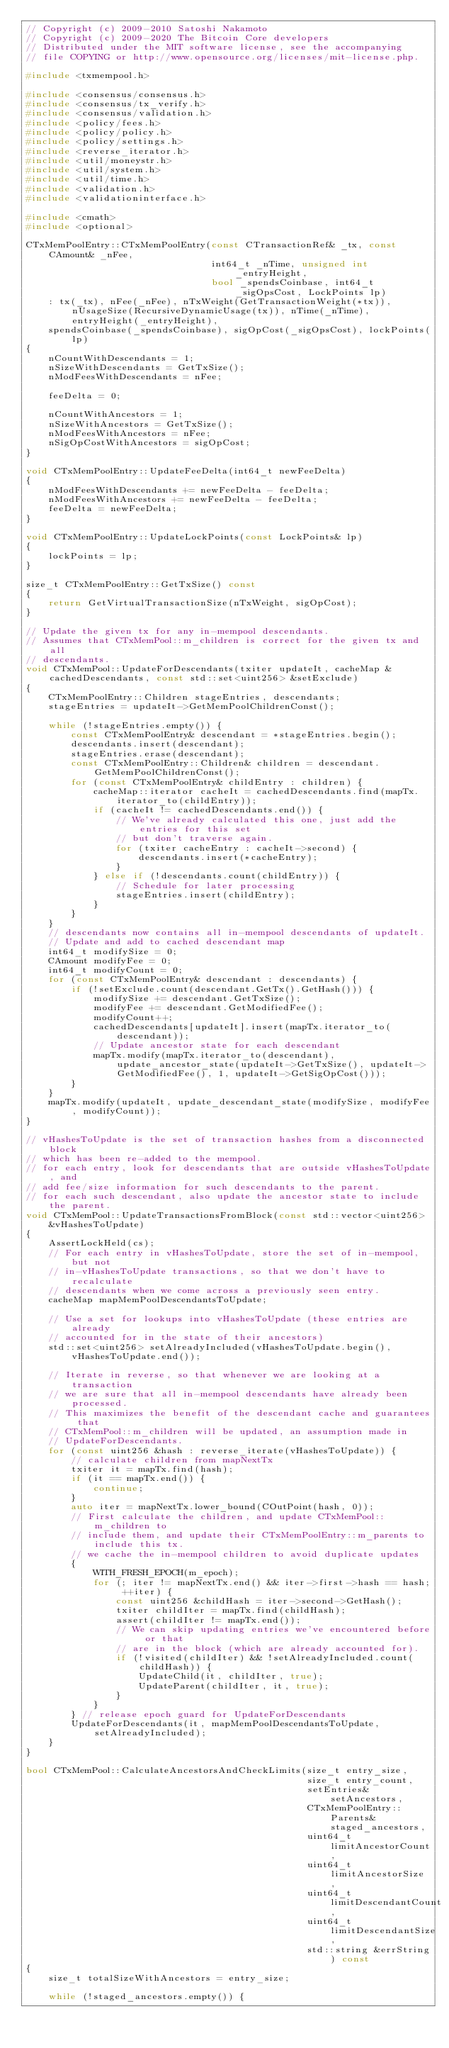Convert code to text. <code><loc_0><loc_0><loc_500><loc_500><_C++_>// Copyright (c) 2009-2010 Satoshi Nakamoto
// Copyright (c) 2009-2020 The Bitcoin Core developers
// Distributed under the MIT software license, see the accompanying
// file COPYING or http://www.opensource.org/licenses/mit-license.php.

#include <txmempool.h>

#include <consensus/consensus.h>
#include <consensus/tx_verify.h>
#include <consensus/validation.h>
#include <policy/fees.h>
#include <policy/policy.h>
#include <policy/settings.h>
#include <reverse_iterator.h>
#include <util/moneystr.h>
#include <util/system.h>
#include <util/time.h>
#include <validation.h>
#include <validationinterface.h>

#include <cmath>
#include <optional>

CTxMemPoolEntry::CTxMemPoolEntry(const CTransactionRef& _tx, const CAmount& _nFee,
                                 int64_t _nTime, unsigned int _entryHeight,
                                 bool _spendsCoinbase, int64_t _sigOpsCost, LockPoints lp)
    : tx(_tx), nFee(_nFee), nTxWeight(GetTransactionWeight(*tx)), nUsageSize(RecursiveDynamicUsage(tx)), nTime(_nTime), entryHeight(_entryHeight),
    spendsCoinbase(_spendsCoinbase), sigOpCost(_sigOpsCost), lockPoints(lp)
{
    nCountWithDescendants = 1;
    nSizeWithDescendants = GetTxSize();
    nModFeesWithDescendants = nFee;

    feeDelta = 0;

    nCountWithAncestors = 1;
    nSizeWithAncestors = GetTxSize();
    nModFeesWithAncestors = nFee;
    nSigOpCostWithAncestors = sigOpCost;
}

void CTxMemPoolEntry::UpdateFeeDelta(int64_t newFeeDelta)
{
    nModFeesWithDescendants += newFeeDelta - feeDelta;
    nModFeesWithAncestors += newFeeDelta - feeDelta;
    feeDelta = newFeeDelta;
}

void CTxMemPoolEntry::UpdateLockPoints(const LockPoints& lp)
{
    lockPoints = lp;
}

size_t CTxMemPoolEntry::GetTxSize() const
{
    return GetVirtualTransactionSize(nTxWeight, sigOpCost);
}

// Update the given tx for any in-mempool descendants.
// Assumes that CTxMemPool::m_children is correct for the given tx and all
// descendants.
void CTxMemPool::UpdateForDescendants(txiter updateIt, cacheMap &cachedDescendants, const std::set<uint256> &setExclude)
{
    CTxMemPoolEntry::Children stageEntries, descendants;
    stageEntries = updateIt->GetMemPoolChildrenConst();

    while (!stageEntries.empty()) {
        const CTxMemPoolEntry& descendant = *stageEntries.begin();
        descendants.insert(descendant);
        stageEntries.erase(descendant);
        const CTxMemPoolEntry::Children& children = descendant.GetMemPoolChildrenConst();
        for (const CTxMemPoolEntry& childEntry : children) {
            cacheMap::iterator cacheIt = cachedDescendants.find(mapTx.iterator_to(childEntry));
            if (cacheIt != cachedDescendants.end()) {
                // We've already calculated this one, just add the entries for this set
                // but don't traverse again.
                for (txiter cacheEntry : cacheIt->second) {
                    descendants.insert(*cacheEntry);
                }
            } else if (!descendants.count(childEntry)) {
                // Schedule for later processing
                stageEntries.insert(childEntry);
            }
        }
    }
    // descendants now contains all in-mempool descendants of updateIt.
    // Update and add to cached descendant map
    int64_t modifySize = 0;
    CAmount modifyFee = 0;
    int64_t modifyCount = 0;
    for (const CTxMemPoolEntry& descendant : descendants) {
        if (!setExclude.count(descendant.GetTx().GetHash())) {
            modifySize += descendant.GetTxSize();
            modifyFee += descendant.GetModifiedFee();
            modifyCount++;
            cachedDescendants[updateIt].insert(mapTx.iterator_to(descendant));
            // Update ancestor state for each descendant
            mapTx.modify(mapTx.iterator_to(descendant), update_ancestor_state(updateIt->GetTxSize(), updateIt->GetModifiedFee(), 1, updateIt->GetSigOpCost()));
        }
    }
    mapTx.modify(updateIt, update_descendant_state(modifySize, modifyFee, modifyCount));
}

// vHashesToUpdate is the set of transaction hashes from a disconnected block
// which has been re-added to the mempool.
// for each entry, look for descendants that are outside vHashesToUpdate, and
// add fee/size information for such descendants to the parent.
// for each such descendant, also update the ancestor state to include the parent.
void CTxMemPool::UpdateTransactionsFromBlock(const std::vector<uint256> &vHashesToUpdate)
{
    AssertLockHeld(cs);
    // For each entry in vHashesToUpdate, store the set of in-mempool, but not
    // in-vHashesToUpdate transactions, so that we don't have to recalculate
    // descendants when we come across a previously seen entry.
    cacheMap mapMemPoolDescendantsToUpdate;

    // Use a set for lookups into vHashesToUpdate (these entries are already
    // accounted for in the state of their ancestors)
    std::set<uint256> setAlreadyIncluded(vHashesToUpdate.begin(), vHashesToUpdate.end());

    // Iterate in reverse, so that whenever we are looking at a transaction
    // we are sure that all in-mempool descendants have already been processed.
    // This maximizes the benefit of the descendant cache and guarantees that
    // CTxMemPool::m_children will be updated, an assumption made in
    // UpdateForDescendants.
    for (const uint256 &hash : reverse_iterate(vHashesToUpdate)) {
        // calculate children from mapNextTx
        txiter it = mapTx.find(hash);
        if (it == mapTx.end()) {
            continue;
        }
        auto iter = mapNextTx.lower_bound(COutPoint(hash, 0));
        // First calculate the children, and update CTxMemPool::m_children to
        // include them, and update their CTxMemPoolEntry::m_parents to include this tx.
        // we cache the in-mempool children to avoid duplicate updates
        {
            WITH_FRESH_EPOCH(m_epoch);
            for (; iter != mapNextTx.end() && iter->first->hash == hash; ++iter) {
                const uint256 &childHash = iter->second->GetHash();
                txiter childIter = mapTx.find(childHash);
                assert(childIter != mapTx.end());
                // We can skip updating entries we've encountered before or that
                // are in the block (which are already accounted for).
                if (!visited(childIter) && !setAlreadyIncluded.count(childHash)) {
                    UpdateChild(it, childIter, true);
                    UpdateParent(childIter, it, true);
                }
            }
        } // release epoch guard for UpdateForDescendants
        UpdateForDescendants(it, mapMemPoolDescendantsToUpdate, setAlreadyIncluded);
    }
}

bool CTxMemPool::CalculateAncestorsAndCheckLimits(size_t entry_size,
                                                  size_t entry_count,
                                                  setEntries& setAncestors,
                                                  CTxMemPoolEntry::Parents& staged_ancestors,
                                                  uint64_t limitAncestorCount,
                                                  uint64_t limitAncestorSize,
                                                  uint64_t limitDescendantCount,
                                                  uint64_t limitDescendantSize,
                                                  std::string &errString) const
{
    size_t totalSizeWithAncestors = entry_size;

    while (!staged_ancestors.empty()) {</code> 